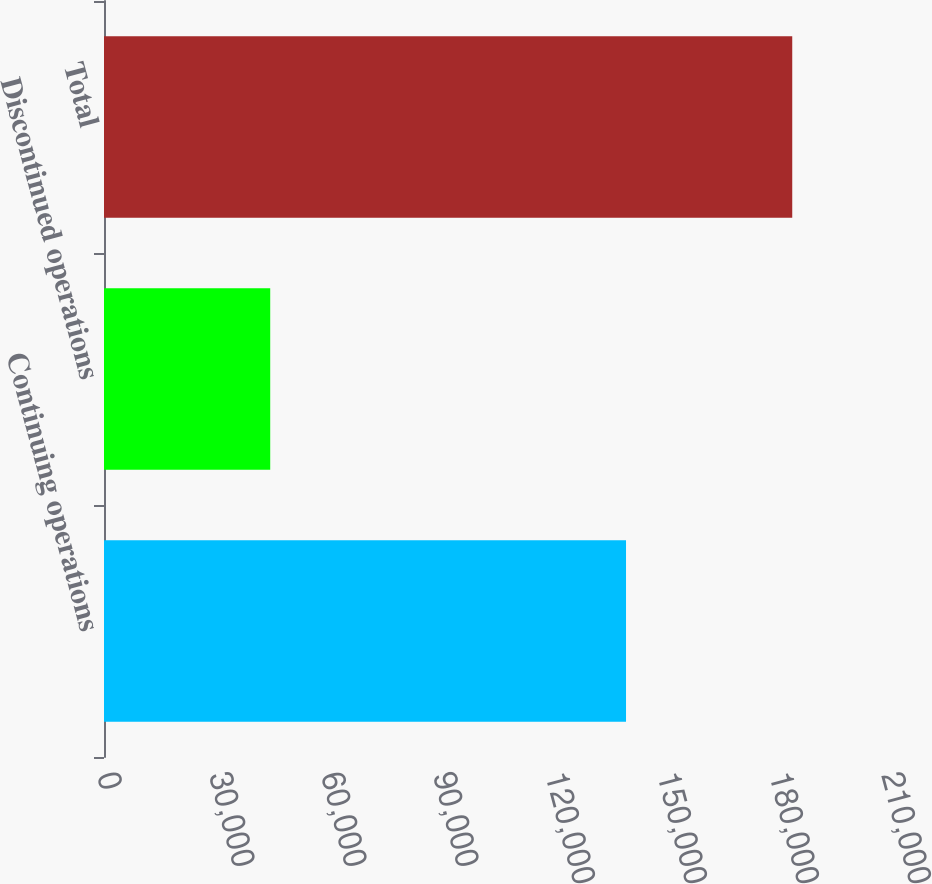Convert chart. <chart><loc_0><loc_0><loc_500><loc_500><bar_chart><fcel>Continuing operations<fcel>Discontinued operations<fcel>Total<nl><fcel>139828<fcel>44522<fcel>184350<nl></chart> 